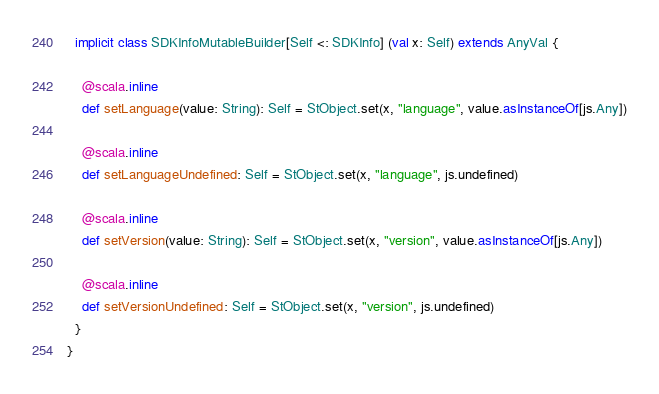Convert code to text. <code><loc_0><loc_0><loc_500><loc_500><_Scala_>  implicit class SDKInfoMutableBuilder[Self <: SDKInfo] (val x: Self) extends AnyVal {
    
    @scala.inline
    def setLanguage(value: String): Self = StObject.set(x, "language", value.asInstanceOf[js.Any])
    
    @scala.inline
    def setLanguageUndefined: Self = StObject.set(x, "language", js.undefined)
    
    @scala.inline
    def setVersion(value: String): Self = StObject.set(x, "version", value.asInstanceOf[js.Any])
    
    @scala.inline
    def setVersionUndefined: Self = StObject.set(x, "version", js.undefined)
  }
}
</code> 